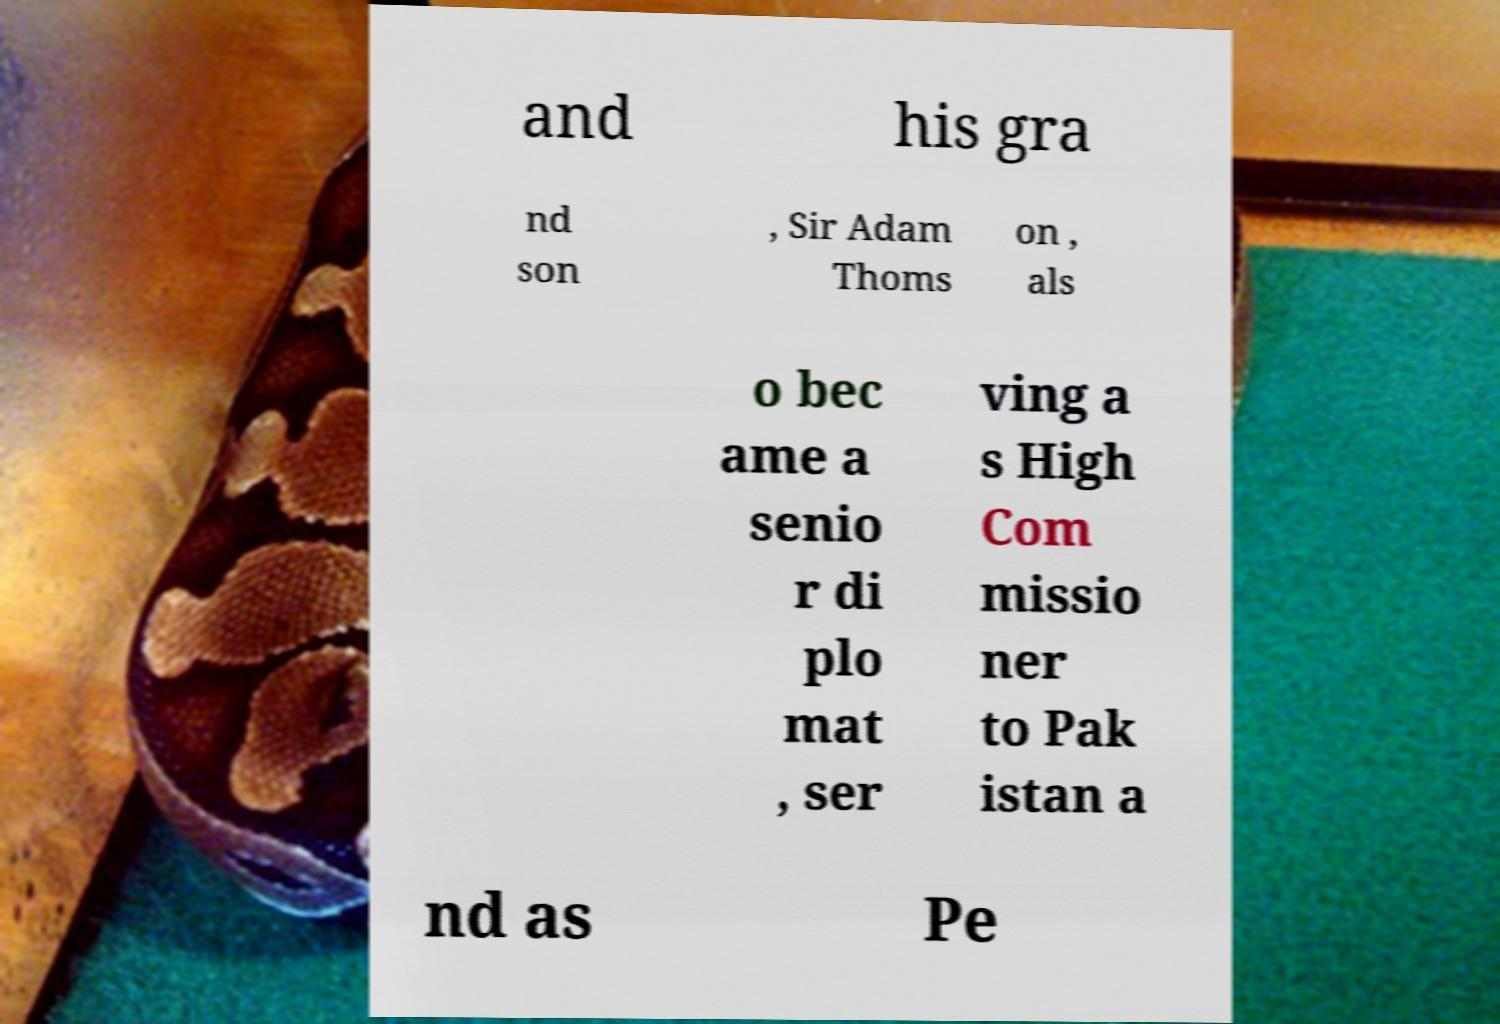What messages or text are displayed in this image? I need them in a readable, typed format. and his gra nd son , Sir Adam Thoms on , als o bec ame a senio r di plo mat , ser ving a s High Com missio ner to Pak istan a nd as Pe 